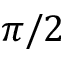<formula> <loc_0><loc_0><loc_500><loc_500>\pi / 2</formula> 